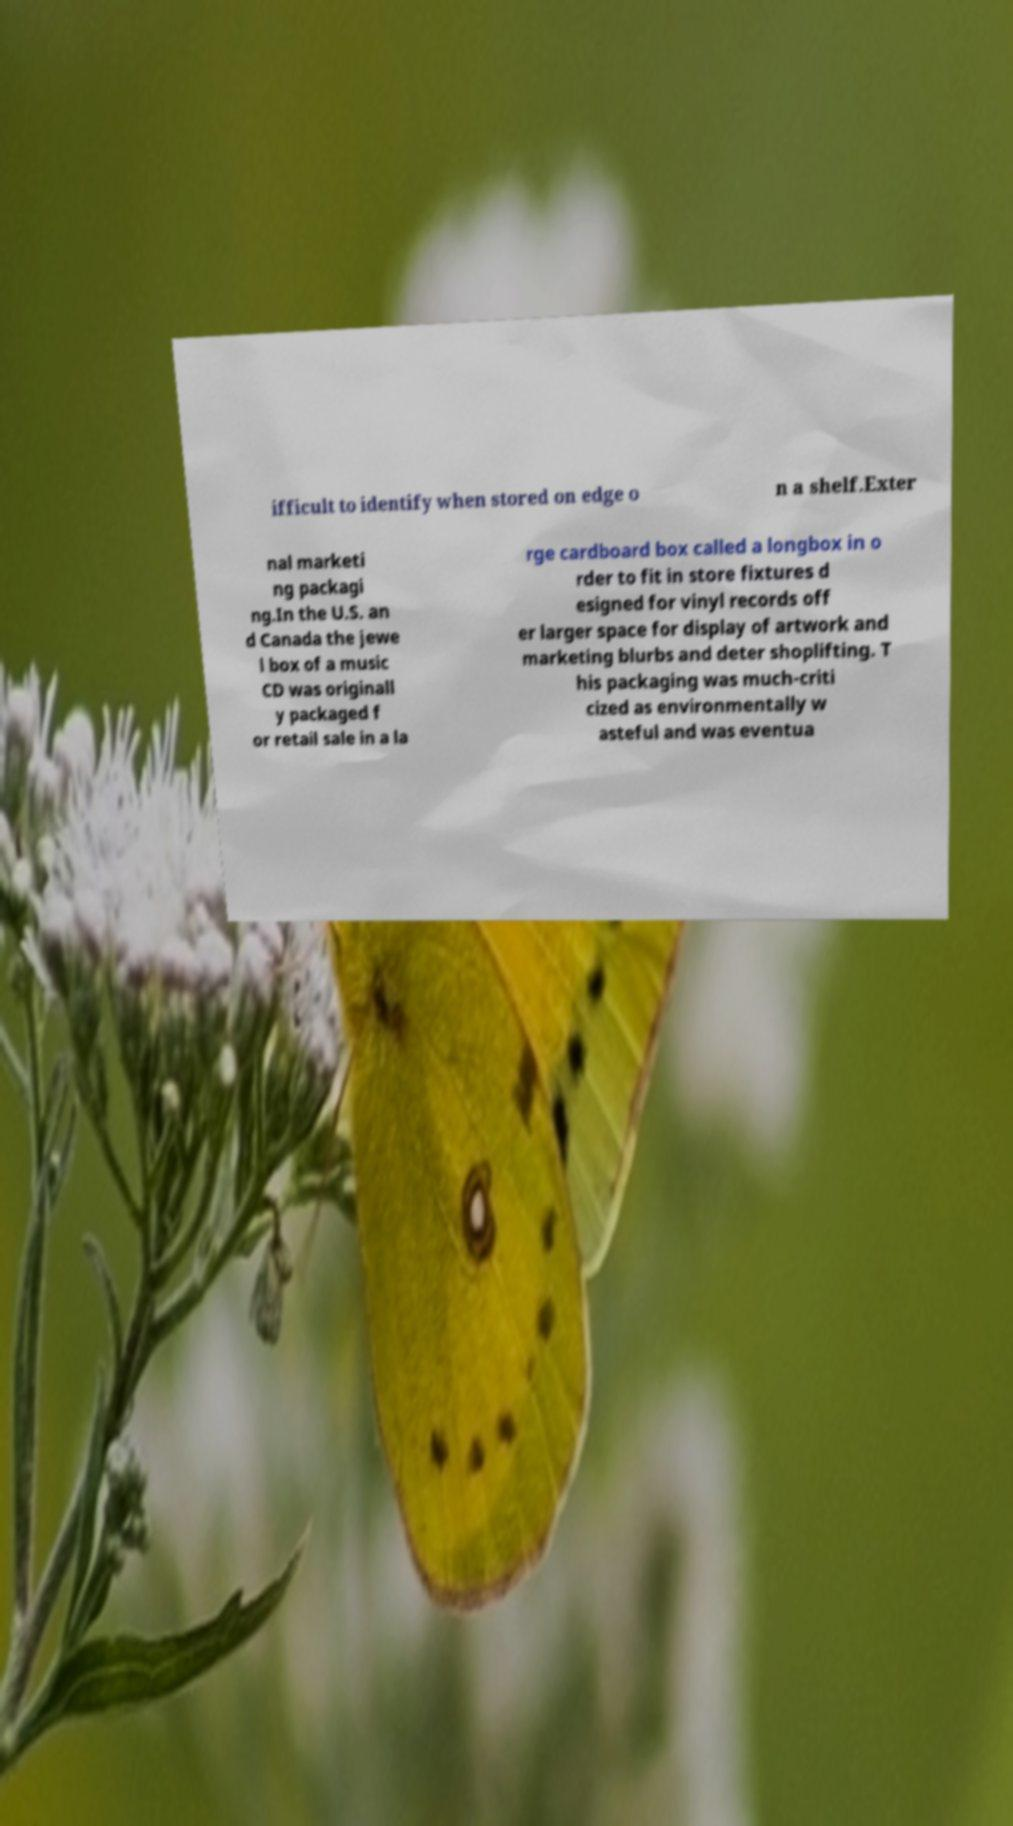Please identify and transcribe the text found in this image. ifficult to identify when stored on edge o n a shelf.Exter nal marketi ng packagi ng.In the U.S. an d Canada the jewe l box of a music CD was originall y packaged f or retail sale in a la rge cardboard box called a longbox in o rder to fit in store fixtures d esigned for vinyl records off er larger space for display of artwork and marketing blurbs and deter shoplifting. T his packaging was much-criti cized as environmentally w asteful and was eventua 